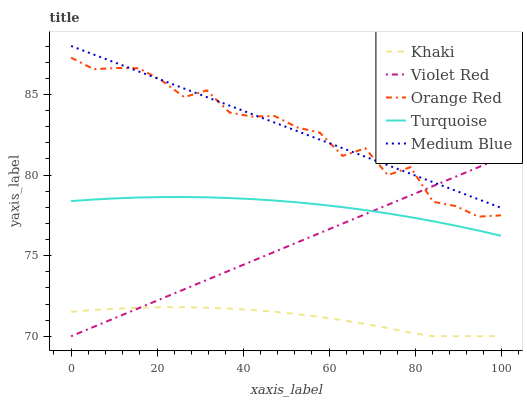Does Khaki have the minimum area under the curve?
Answer yes or no. Yes. Does Medium Blue have the maximum area under the curve?
Answer yes or no. Yes. Does Medium Blue have the minimum area under the curve?
Answer yes or no. No. Does Khaki have the maximum area under the curve?
Answer yes or no. No. Is Violet Red the smoothest?
Answer yes or no. Yes. Is Orange Red the roughest?
Answer yes or no. Yes. Is Khaki the smoothest?
Answer yes or no. No. Is Khaki the roughest?
Answer yes or no. No. Does Violet Red have the lowest value?
Answer yes or no. Yes. Does Medium Blue have the lowest value?
Answer yes or no. No. Does Medium Blue have the highest value?
Answer yes or no. Yes. Does Khaki have the highest value?
Answer yes or no. No. Is Khaki less than Orange Red?
Answer yes or no. Yes. Is Medium Blue greater than Khaki?
Answer yes or no. Yes. Does Orange Red intersect Violet Red?
Answer yes or no. Yes. Is Orange Red less than Violet Red?
Answer yes or no. No. Is Orange Red greater than Violet Red?
Answer yes or no. No. Does Khaki intersect Orange Red?
Answer yes or no. No. 